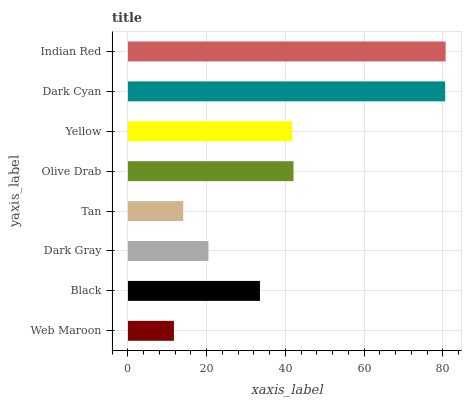Is Web Maroon the minimum?
Answer yes or no. Yes. Is Indian Red the maximum?
Answer yes or no. Yes. Is Black the minimum?
Answer yes or no. No. Is Black the maximum?
Answer yes or no. No. Is Black greater than Web Maroon?
Answer yes or no. Yes. Is Web Maroon less than Black?
Answer yes or no. Yes. Is Web Maroon greater than Black?
Answer yes or no. No. Is Black less than Web Maroon?
Answer yes or no. No. Is Yellow the high median?
Answer yes or no. Yes. Is Black the low median?
Answer yes or no. Yes. Is Indian Red the high median?
Answer yes or no. No. Is Dark Gray the low median?
Answer yes or no. No. 